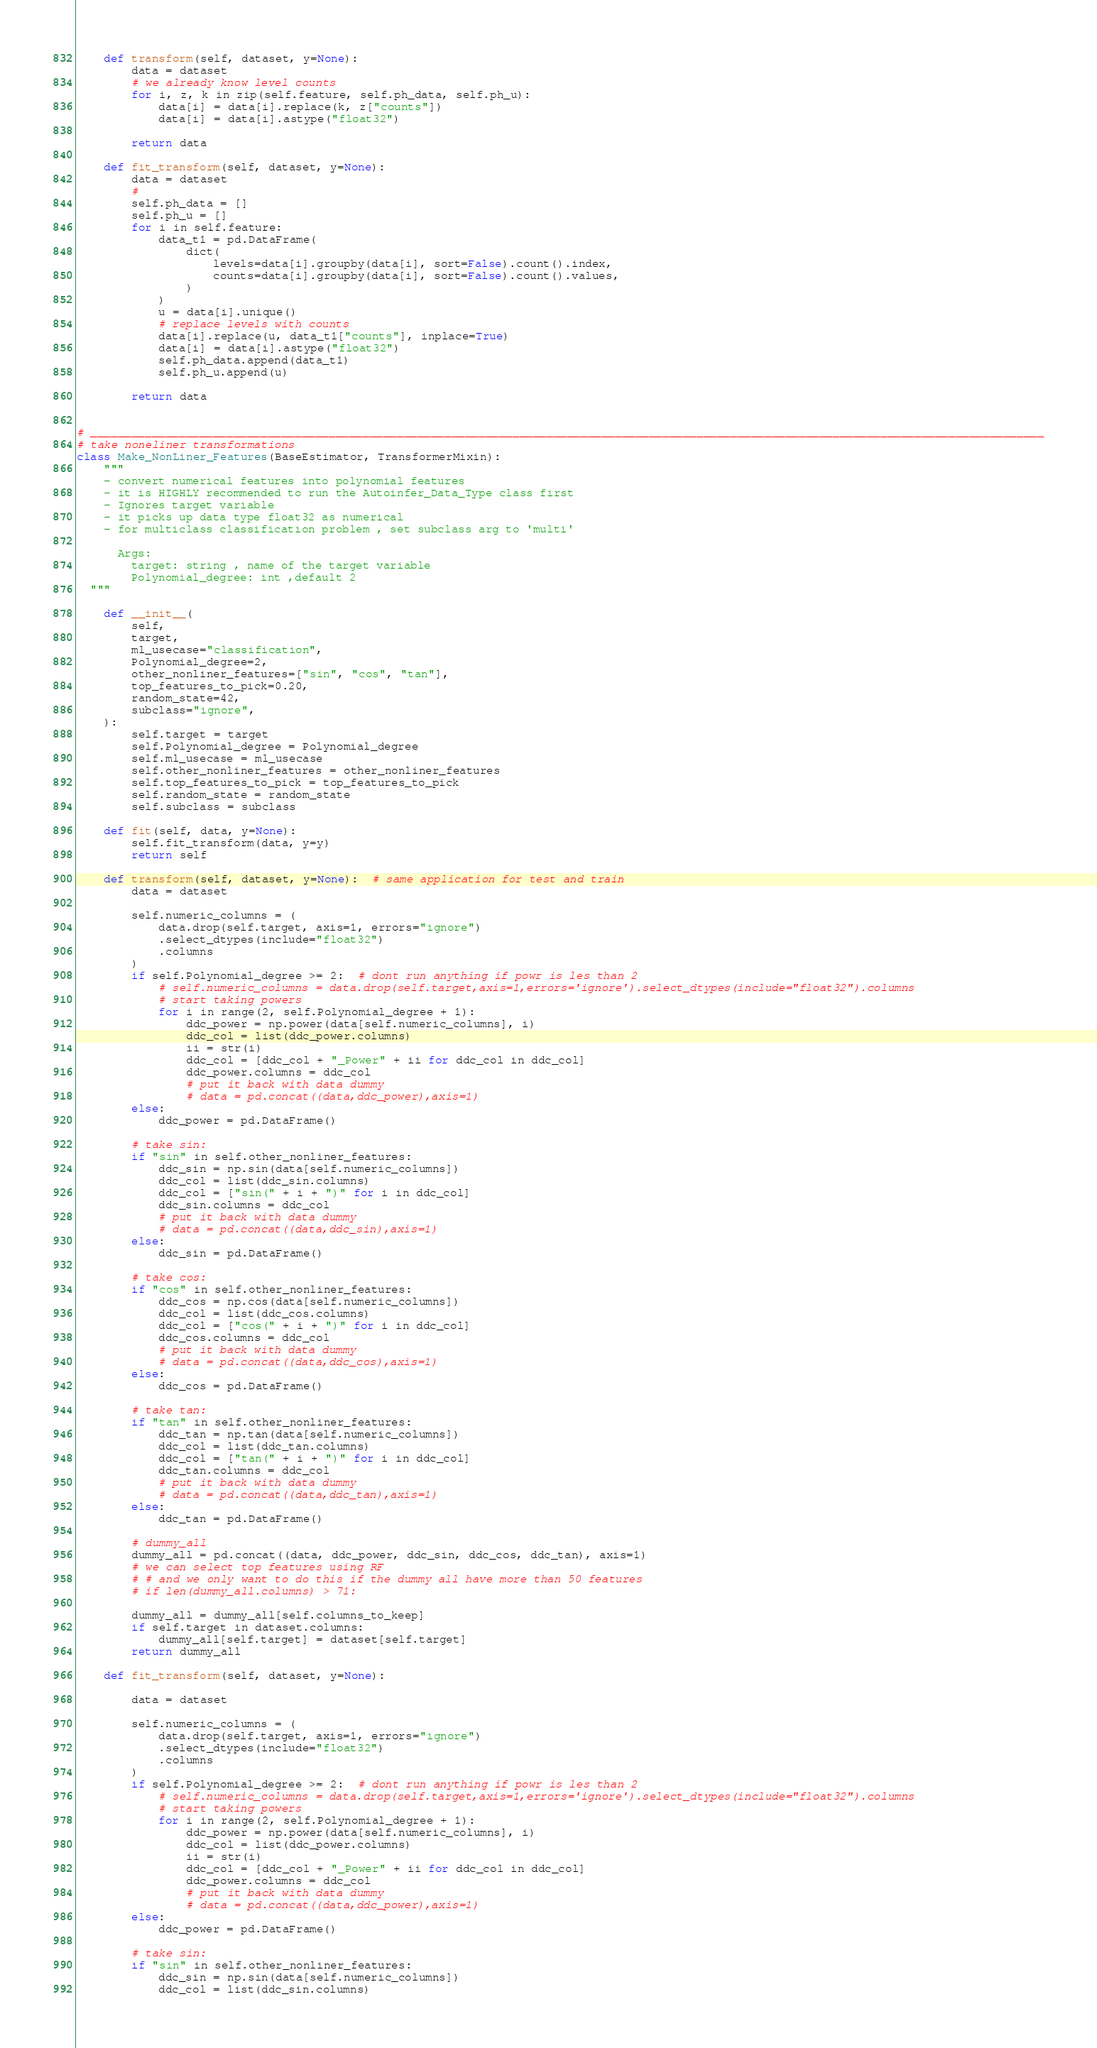<code> <loc_0><loc_0><loc_500><loc_500><_Python_>
    def transform(self, dataset, y=None):
        data = dataset
        # we already know level counts
        for i, z, k in zip(self.feature, self.ph_data, self.ph_u):
            data[i] = data[i].replace(k, z["counts"])
            data[i] = data[i].astype("float32")

        return data

    def fit_transform(self, dataset, y=None):
        data = dataset
        #
        self.ph_data = []
        self.ph_u = []
        for i in self.feature:
            data_t1 = pd.DataFrame(
                dict(
                    levels=data[i].groupby(data[i], sort=False).count().index,
                    counts=data[i].groupby(data[i], sort=False).count().values,
                )
            )
            u = data[i].unique()
            # replace levels with counts
            data[i].replace(u, data_t1["counts"], inplace=True)
            data[i] = data[i].astype("float32")
            self.ph_data.append(data_t1)
            self.ph_u.append(u)

        return data


# ____________________________________________________________________________________________________________________________________________
# take noneliner transformations
class Make_NonLiner_Features(BaseEstimator, TransformerMixin):
    """
    - convert numerical features into polynomial features
    - it is HIGHLY recommended to run the Autoinfer_Data_Type class first
    - Ignores target variable
    - it picks up data type float32 as numerical 
    - for multiclass classification problem , set subclass arg to 'multi'

      Args: 
        target: string , name of the target variable
        Polynomial_degree: int ,default 2  
  """

    def __init__(
        self,
        target,
        ml_usecase="classification",
        Polynomial_degree=2,
        other_nonliner_features=["sin", "cos", "tan"],
        top_features_to_pick=0.20,
        random_state=42,
        subclass="ignore",
    ):
        self.target = target
        self.Polynomial_degree = Polynomial_degree
        self.ml_usecase = ml_usecase
        self.other_nonliner_features = other_nonliner_features
        self.top_features_to_pick = top_features_to_pick
        self.random_state = random_state
        self.subclass = subclass

    def fit(self, data, y=None):
        self.fit_transform(data, y=y)
        return self

    def transform(self, dataset, y=None):  # same application for test and train
        data = dataset

        self.numeric_columns = (
            data.drop(self.target, axis=1, errors="ignore")
            .select_dtypes(include="float32")
            .columns
        )
        if self.Polynomial_degree >= 2:  # dont run anything if powr is les than 2
            # self.numeric_columns = data.drop(self.target,axis=1,errors='ignore').select_dtypes(include="float32").columns
            # start taking powers
            for i in range(2, self.Polynomial_degree + 1):
                ddc_power = np.power(data[self.numeric_columns], i)
                ddc_col = list(ddc_power.columns)
                ii = str(i)
                ddc_col = [ddc_col + "_Power" + ii for ddc_col in ddc_col]
                ddc_power.columns = ddc_col
                # put it back with data dummy
                # data = pd.concat((data,ddc_power),axis=1)
        else:
            ddc_power = pd.DataFrame()

        # take sin:
        if "sin" in self.other_nonliner_features:
            ddc_sin = np.sin(data[self.numeric_columns])
            ddc_col = list(ddc_sin.columns)
            ddc_col = ["sin(" + i + ")" for i in ddc_col]
            ddc_sin.columns = ddc_col
            # put it back with data dummy
            # data = pd.concat((data,ddc_sin),axis=1)
        else:
            ddc_sin = pd.DataFrame()

        # take cos:
        if "cos" in self.other_nonliner_features:
            ddc_cos = np.cos(data[self.numeric_columns])
            ddc_col = list(ddc_cos.columns)
            ddc_col = ["cos(" + i + ")" for i in ddc_col]
            ddc_cos.columns = ddc_col
            # put it back with data dummy
            # data = pd.concat((data,ddc_cos),axis=1)
        else:
            ddc_cos = pd.DataFrame()

        # take tan:
        if "tan" in self.other_nonliner_features:
            ddc_tan = np.tan(data[self.numeric_columns])
            ddc_col = list(ddc_tan.columns)
            ddc_col = ["tan(" + i + ")" for i in ddc_col]
            ddc_tan.columns = ddc_col
            # put it back with data dummy
            # data = pd.concat((data,ddc_tan),axis=1)
        else:
            ddc_tan = pd.DataFrame()

        # dummy_all
        dummy_all = pd.concat((data, ddc_power, ddc_sin, ddc_cos, ddc_tan), axis=1)
        # we can select top features using RF
        # # and we only want to do this if the dummy all have more than 50 features
        # if len(dummy_all.columns) > 71:

        dummy_all = dummy_all[self.columns_to_keep]
        if self.target in dataset.columns:
            dummy_all[self.target] = dataset[self.target]
        return dummy_all

    def fit_transform(self, dataset, y=None):

        data = dataset

        self.numeric_columns = (
            data.drop(self.target, axis=1, errors="ignore")
            .select_dtypes(include="float32")
            .columns
        )
        if self.Polynomial_degree >= 2:  # dont run anything if powr is les than 2
            # self.numeric_columns = data.drop(self.target,axis=1,errors='ignore').select_dtypes(include="float32").columns
            # start taking powers
            for i in range(2, self.Polynomial_degree + 1):
                ddc_power = np.power(data[self.numeric_columns], i)
                ddc_col = list(ddc_power.columns)
                ii = str(i)
                ddc_col = [ddc_col + "_Power" + ii for ddc_col in ddc_col]
                ddc_power.columns = ddc_col
                # put it back with data dummy
                # data = pd.concat((data,ddc_power),axis=1)
        else:
            ddc_power = pd.DataFrame()

        # take sin:
        if "sin" in self.other_nonliner_features:
            ddc_sin = np.sin(data[self.numeric_columns])
            ddc_col = list(ddc_sin.columns)</code> 